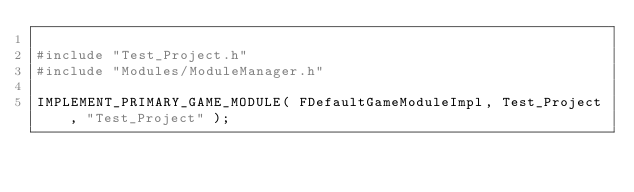<code> <loc_0><loc_0><loc_500><loc_500><_C++_>
#include "Test_Project.h"
#include "Modules/ModuleManager.h"

IMPLEMENT_PRIMARY_GAME_MODULE( FDefaultGameModuleImpl, Test_Project, "Test_Project" );
</code> 